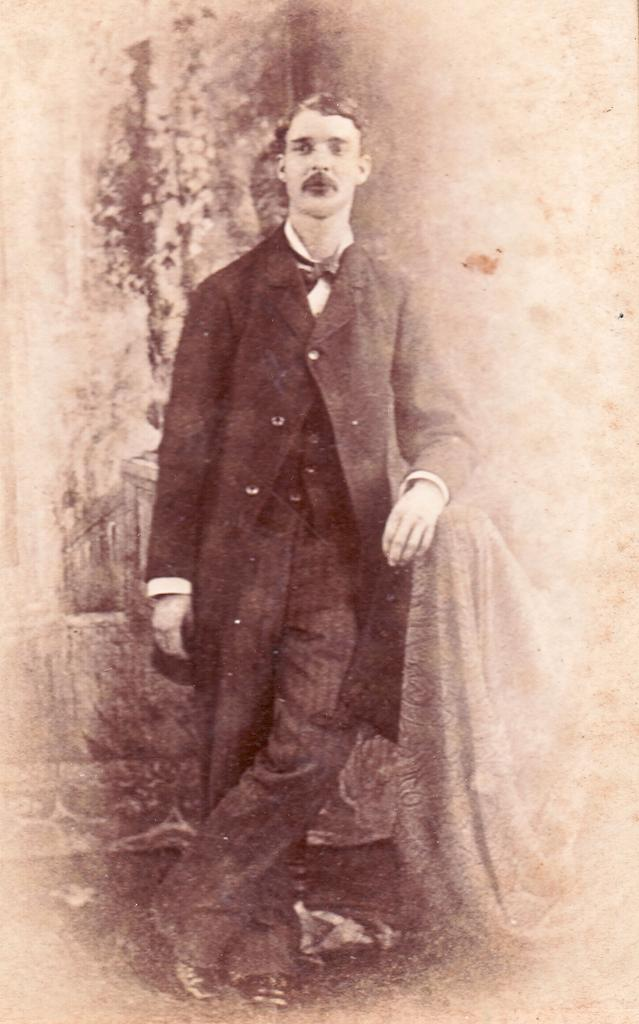What is the main subject of the image? There is a person standing in the image. What is the person wearing? The person is wearing a dress. What can be seen in the background of the image? There is a wall visible in the background of the image. What is the color scheme of the image? The image is black and white. What type of farm animals can be seen in the image? There are no farm animals present in the image. What authority figure is depicted in the image? There is no authority figure depicted in the image; it features a person standing in a black and white setting. 